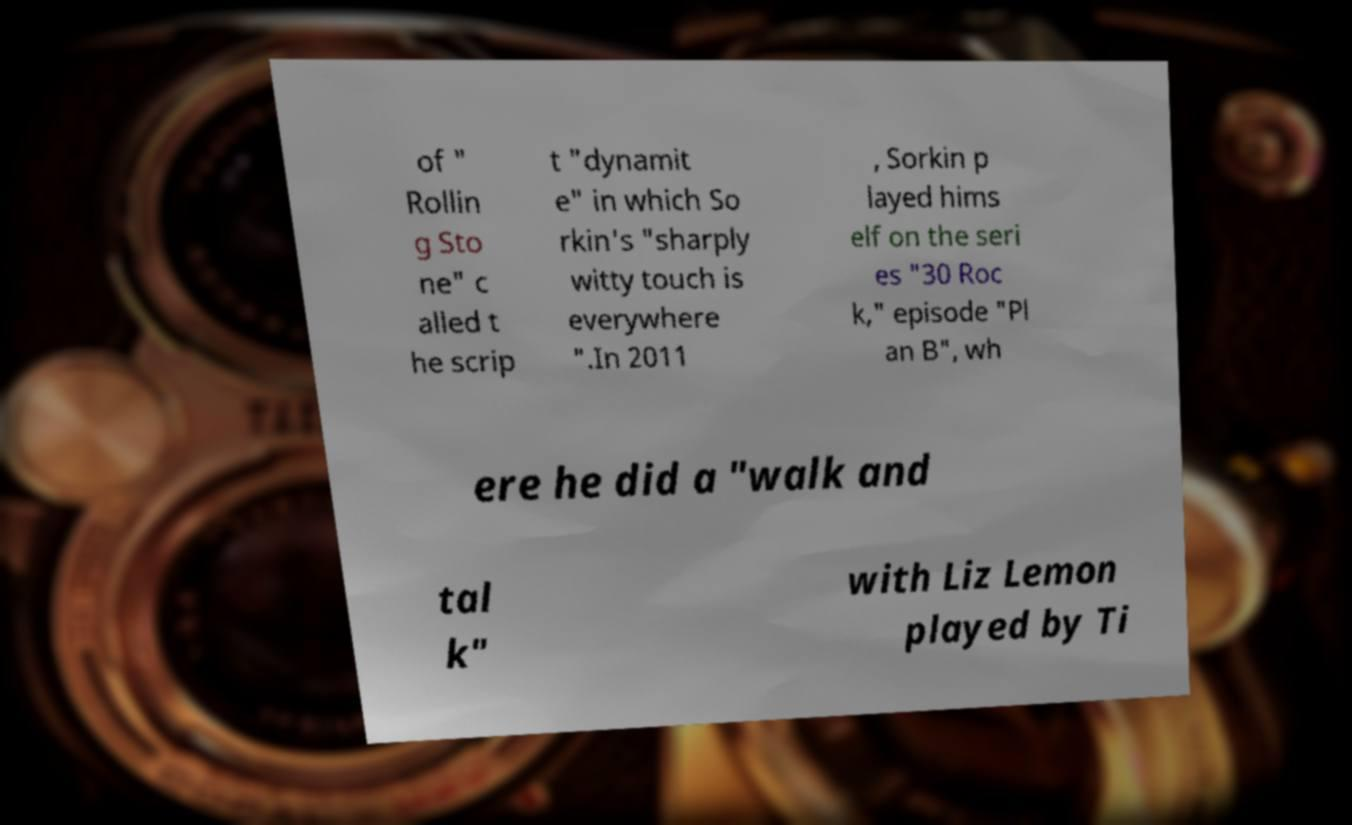Please identify and transcribe the text found in this image. of " Rollin g Sto ne" c alled t he scrip t "dynamit e" in which So rkin's "sharply witty touch is everywhere ".In 2011 , Sorkin p layed hims elf on the seri es "30 Roc k," episode "Pl an B", wh ere he did a "walk and tal k" with Liz Lemon played by Ti 